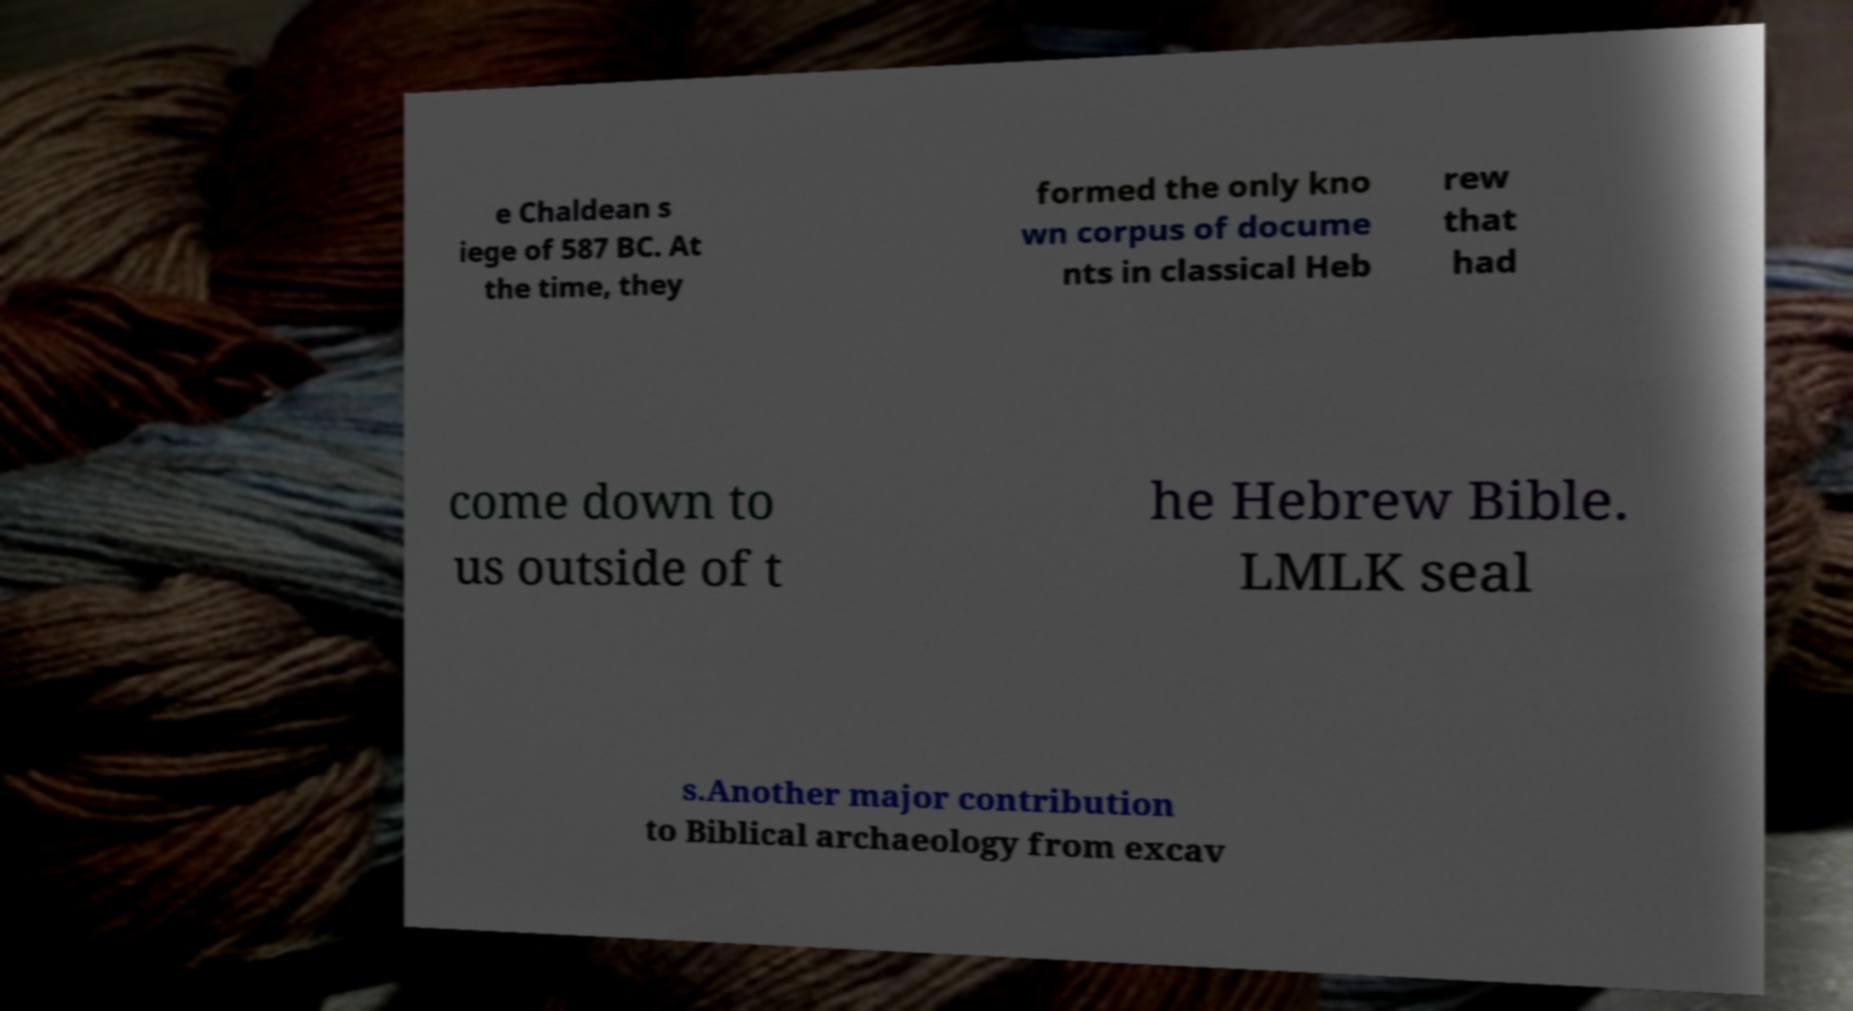Can you read and provide the text displayed in the image?This photo seems to have some interesting text. Can you extract and type it out for me? e Chaldean s iege of 587 BC. At the time, they formed the only kno wn corpus of docume nts in classical Heb rew that had come down to us outside of t he Hebrew Bible. LMLK seal s.Another major contribution to Biblical archaeology from excav 